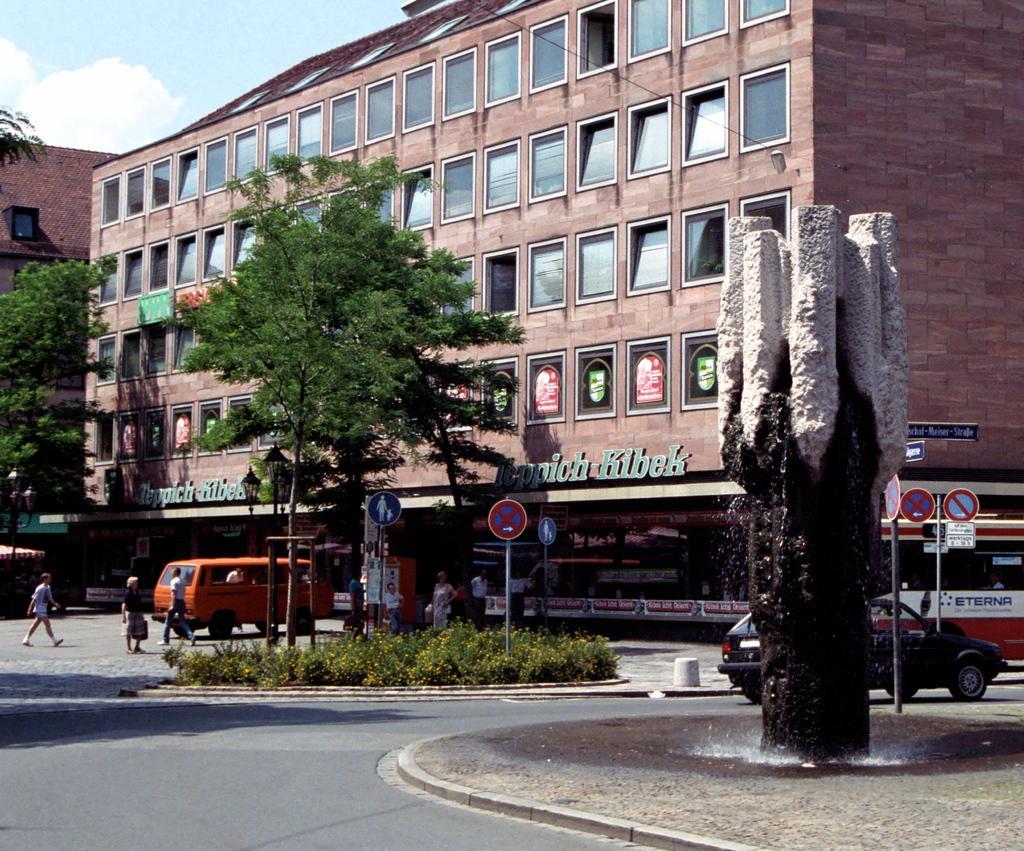Describe this image in one or two sentences. There is a tree, sign boards are present. There are people, vehicles and buildings. 